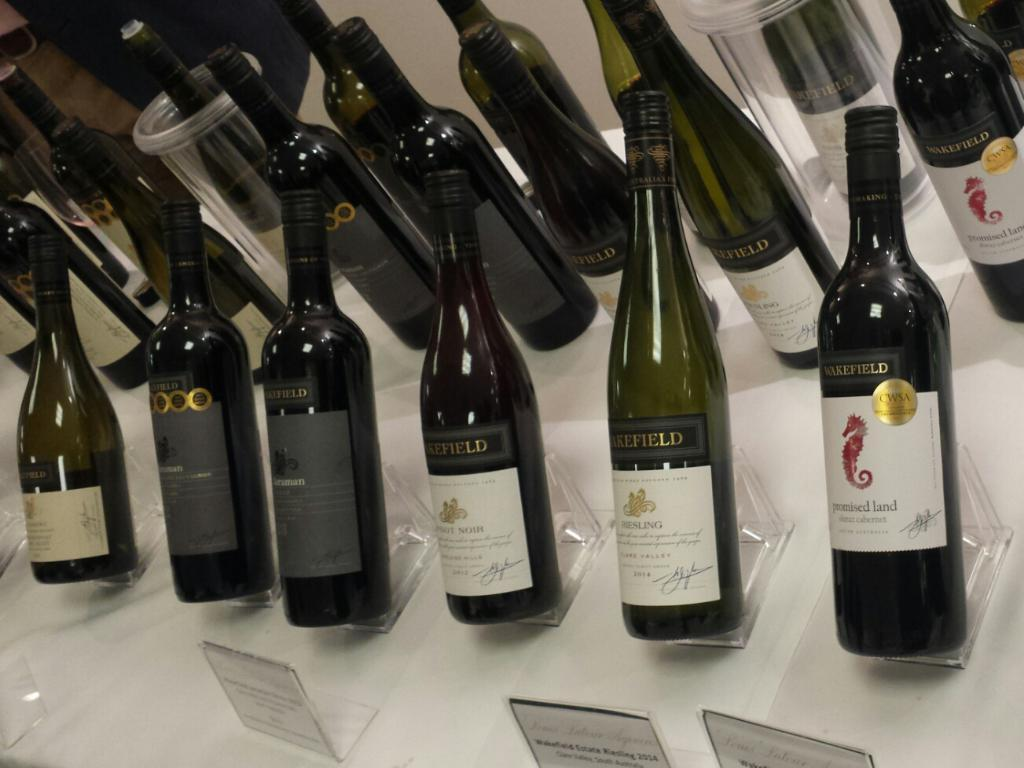What objects are placed on the table in the image? There are bottles placed on a table in the image. Are there any additional items associated with the bottles? Yes, there are name plates behind and in front of the bottles. Can you describe the location of the glass in the image? There is a glass in the right corner of the image. What type of lace can be seen on the bottles in the image? There is no lace present on the bottles in the image. How many planes are flying in the background of the image? There are no planes visible in the image. 